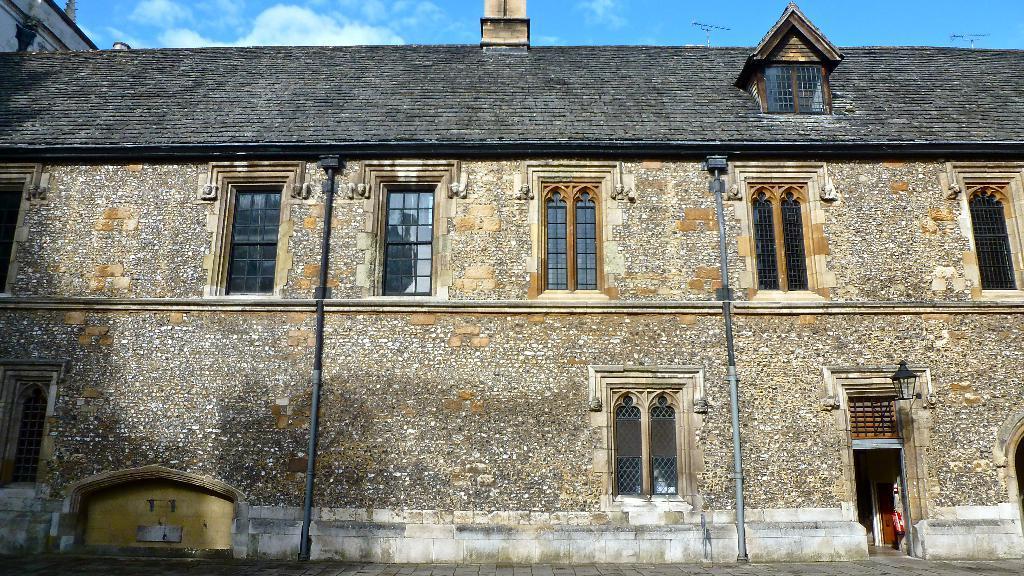Could you give a brief overview of what you see in this image? There is a stone building. There is a door and a lamp at the right. There are windows. 